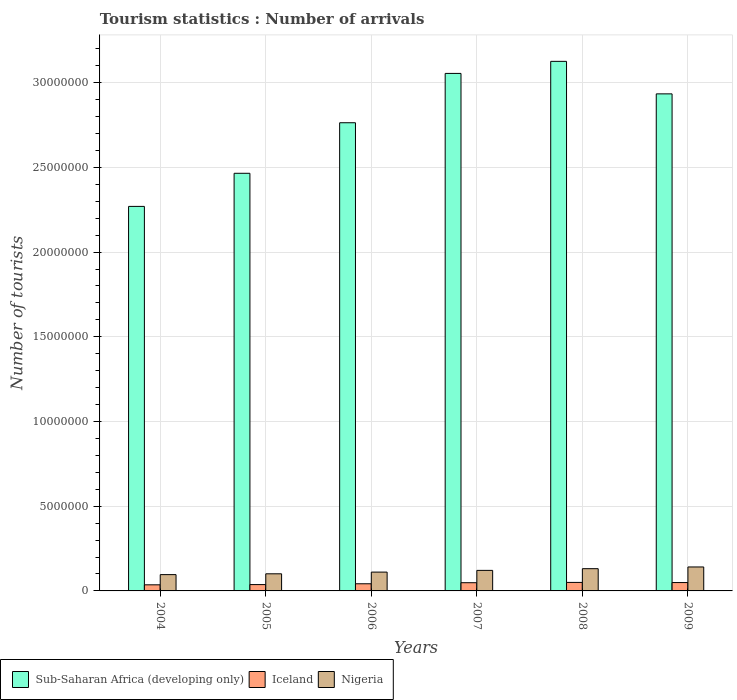How many different coloured bars are there?
Your response must be concise. 3. How many groups of bars are there?
Make the answer very short. 6. Are the number of bars on each tick of the X-axis equal?
Your answer should be very brief. Yes. How many bars are there on the 3rd tick from the left?
Provide a succinct answer. 3. How many bars are there on the 2nd tick from the right?
Make the answer very short. 3. What is the label of the 1st group of bars from the left?
Give a very brief answer. 2004. What is the number of tourist arrivals in Sub-Saharan Africa (developing only) in 2005?
Keep it short and to the point. 2.47e+07. Across all years, what is the maximum number of tourist arrivals in Nigeria?
Offer a terse response. 1.41e+06. Across all years, what is the minimum number of tourist arrivals in Sub-Saharan Africa (developing only)?
Give a very brief answer. 2.27e+07. In which year was the number of tourist arrivals in Sub-Saharan Africa (developing only) maximum?
Keep it short and to the point. 2008. In which year was the number of tourist arrivals in Nigeria minimum?
Provide a short and direct response. 2004. What is the total number of tourist arrivals in Nigeria in the graph?
Keep it short and to the point. 7.02e+06. What is the difference between the number of tourist arrivals in Nigeria in 2004 and that in 2006?
Your response must be concise. -1.49e+05. What is the difference between the number of tourist arrivals in Sub-Saharan Africa (developing only) in 2006 and the number of tourist arrivals in Nigeria in 2004?
Your answer should be compact. 2.67e+07. What is the average number of tourist arrivals in Sub-Saharan Africa (developing only) per year?
Provide a short and direct response. 2.77e+07. In the year 2005, what is the difference between the number of tourist arrivals in Sub-Saharan Africa (developing only) and number of tourist arrivals in Iceland?
Ensure brevity in your answer.  2.43e+07. What is the ratio of the number of tourist arrivals in Sub-Saharan Africa (developing only) in 2004 to that in 2006?
Provide a short and direct response. 0.82. What is the difference between the highest and the second highest number of tourist arrivals in Nigeria?
Keep it short and to the point. 1.01e+05. What is the difference between the highest and the lowest number of tourist arrivals in Nigeria?
Ensure brevity in your answer.  4.52e+05. In how many years, is the number of tourist arrivals in Nigeria greater than the average number of tourist arrivals in Nigeria taken over all years?
Offer a very short reply. 3. Is the sum of the number of tourist arrivals in Iceland in 2004 and 2005 greater than the maximum number of tourist arrivals in Nigeria across all years?
Give a very brief answer. No. What does the 3rd bar from the left in 2009 represents?
Your answer should be compact. Nigeria. How many bars are there?
Your answer should be compact. 18. How many years are there in the graph?
Give a very brief answer. 6. What is the difference between two consecutive major ticks on the Y-axis?
Offer a very short reply. 5.00e+06. Does the graph contain grids?
Provide a short and direct response. Yes. What is the title of the graph?
Ensure brevity in your answer.  Tourism statistics : Number of arrivals. What is the label or title of the X-axis?
Offer a terse response. Years. What is the label or title of the Y-axis?
Your response must be concise. Number of tourists. What is the Number of tourists in Sub-Saharan Africa (developing only) in 2004?
Offer a very short reply. 2.27e+07. What is the Number of tourists in Iceland in 2004?
Your answer should be very brief. 3.60e+05. What is the Number of tourists of Nigeria in 2004?
Ensure brevity in your answer.  9.62e+05. What is the Number of tourists in Sub-Saharan Africa (developing only) in 2005?
Provide a short and direct response. 2.47e+07. What is the Number of tourists in Iceland in 2005?
Provide a short and direct response. 3.74e+05. What is the Number of tourists in Nigeria in 2005?
Offer a terse response. 1.01e+06. What is the Number of tourists in Sub-Saharan Africa (developing only) in 2006?
Make the answer very short. 2.76e+07. What is the Number of tourists of Iceland in 2006?
Your answer should be compact. 4.22e+05. What is the Number of tourists of Nigeria in 2006?
Your response must be concise. 1.11e+06. What is the Number of tourists of Sub-Saharan Africa (developing only) in 2007?
Provide a short and direct response. 3.05e+07. What is the Number of tourists in Iceland in 2007?
Your response must be concise. 4.85e+05. What is the Number of tourists of Nigeria in 2007?
Provide a short and direct response. 1.21e+06. What is the Number of tourists in Sub-Saharan Africa (developing only) in 2008?
Your answer should be very brief. 3.13e+07. What is the Number of tourists in Iceland in 2008?
Your response must be concise. 5.02e+05. What is the Number of tourists in Nigeria in 2008?
Your answer should be compact. 1.31e+06. What is the Number of tourists in Sub-Saharan Africa (developing only) in 2009?
Give a very brief answer. 2.93e+07. What is the Number of tourists of Iceland in 2009?
Your answer should be very brief. 4.94e+05. What is the Number of tourists of Nigeria in 2009?
Your answer should be compact. 1.41e+06. Across all years, what is the maximum Number of tourists in Sub-Saharan Africa (developing only)?
Give a very brief answer. 3.13e+07. Across all years, what is the maximum Number of tourists in Iceland?
Give a very brief answer. 5.02e+05. Across all years, what is the maximum Number of tourists in Nigeria?
Your answer should be compact. 1.41e+06. Across all years, what is the minimum Number of tourists in Sub-Saharan Africa (developing only)?
Offer a terse response. 2.27e+07. Across all years, what is the minimum Number of tourists of Iceland?
Your answer should be very brief. 3.60e+05. Across all years, what is the minimum Number of tourists in Nigeria?
Offer a terse response. 9.62e+05. What is the total Number of tourists in Sub-Saharan Africa (developing only) in the graph?
Your answer should be very brief. 1.66e+08. What is the total Number of tourists of Iceland in the graph?
Provide a succinct answer. 2.64e+06. What is the total Number of tourists of Nigeria in the graph?
Ensure brevity in your answer.  7.02e+06. What is the difference between the Number of tourists of Sub-Saharan Africa (developing only) in 2004 and that in 2005?
Your answer should be compact. -1.95e+06. What is the difference between the Number of tourists in Iceland in 2004 and that in 2005?
Your response must be concise. -1.40e+04. What is the difference between the Number of tourists in Nigeria in 2004 and that in 2005?
Give a very brief answer. -4.80e+04. What is the difference between the Number of tourists in Sub-Saharan Africa (developing only) in 2004 and that in 2006?
Offer a terse response. -4.94e+06. What is the difference between the Number of tourists of Iceland in 2004 and that in 2006?
Offer a very short reply. -6.20e+04. What is the difference between the Number of tourists in Nigeria in 2004 and that in 2006?
Your answer should be compact. -1.49e+05. What is the difference between the Number of tourists in Sub-Saharan Africa (developing only) in 2004 and that in 2007?
Provide a short and direct response. -7.85e+06. What is the difference between the Number of tourists of Iceland in 2004 and that in 2007?
Provide a short and direct response. -1.25e+05. What is the difference between the Number of tourists of Sub-Saharan Africa (developing only) in 2004 and that in 2008?
Ensure brevity in your answer.  -8.56e+06. What is the difference between the Number of tourists in Iceland in 2004 and that in 2008?
Make the answer very short. -1.42e+05. What is the difference between the Number of tourists in Nigeria in 2004 and that in 2008?
Provide a succinct answer. -3.51e+05. What is the difference between the Number of tourists in Sub-Saharan Africa (developing only) in 2004 and that in 2009?
Your answer should be very brief. -6.64e+06. What is the difference between the Number of tourists of Iceland in 2004 and that in 2009?
Provide a succinct answer. -1.34e+05. What is the difference between the Number of tourists in Nigeria in 2004 and that in 2009?
Give a very brief answer. -4.52e+05. What is the difference between the Number of tourists in Sub-Saharan Africa (developing only) in 2005 and that in 2006?
Give a very brief answer. -2.98e+06. What is the difference between the Number of tourists of Iceland in 2005 and that in 2006?
Make the answer very short. -4.80e+04. What is the difference between the Number of tourists of Nigeria in 2005 and that in 2006?
Offer a terse response. -1.01e+05. What is the difference between the Number of tourists of Sub-Saharan Africa (developing only) in 2005 and that in 2007?
Your response must be concise. -5.89e+06. What is the difference between the Number of tourists in Iceland in 2005 and that in 2007?
Ensure brevity in your answer.  -1.11e+05. What is the difference between the Number of tourists in Nigeria in 2005 and that in 2007?
Offer a terse response. -2.02e+05. What is the difference between the Number of tourists of Sub-Saharan Africa (developing only) in 2005 and that in 2008?
Keep it short and to the point. -6.61e+06. What is the difference between the Number of tourists of Iceland in 2005 and that in 2008?
Offer a very short reply. -1.28e+05. What is the difference between the Number of tourists in Nigeria in 2005 and that in 2008?
Your answer should be compact. -3.03e+05. What is the difference between the Number of tourists of Sub-Saharan Africa (developing only) in 2005 and that in 2009?
Give a very brief answer. -4.69e+06. What is the difference between the Number of tourists of Nigeria in 2005 and that in 2009?
Your answer should be compact. -4.04e+05. What is the difference between the Number of tourists of Sub-Saharan Africa (developing only) in 2006 and that in 2007?
Provide a succinct answer. -2.91e+06. What is the difference between the Number of tourists in Iceland in 2006 and that in 2007?
Offer a very short reply. -6.30e+04. What is the difference between the Number of tourists of Nigeria in 2006 and that in 2007?
Your answer should be compact. -1.01e+05. What is the difference between the Number of tourists of Sub-Saharan Africa (developing only) in 2006 and that in 2008?
Give a very brief answer. -3.62e+06. What is the difference between the Number of tourists of Iceland in 2006 and that in 2008?
Offer a very short reply. -8.00e+04. What is the difference between the Number of tourists of Nigeria in 2006 and that in 2008?
Ensure brevity in your answer.  -2.02e+05. What is the difference between the Number of tourists in Sub-Saharan Africa (developing only) in 2006 and that in 2009?
Keep it short and to the point. -1.70e+06. What is the difference between the Number of tourists of Iceland in 2006 and that in 2009?
Your response must be concise. -7.20e+04. What is the difference between the Number of tourists of Nigeria in 2006 and that in 2009?
Make the answer very short. -3.03e+05. What is the difference between the Number of tourists in Sub-Saharan Africa (developing only) in 2007 and that in 2008?
Ensure brevity in your answer.  -7.12e+05. What is the difference between the Number of tourists of Iceland in 2007 and that in 2008?
Make the answer very short. -1.70e+04. What is the difference between the Number of tourists of Nigeria in 2007 and that in 2008?
Make the answer very short. -1.01e+05. What is the difference between the Number of tourists of Sub-Saharan Africa (developing only) in 2007 and that in 2009?
Your response must be concise. 1.21e+06. What is the difference between the Number of tourists of Iceland in 2007 and that in 2009?
Keep it short and to the point. -9000. What is the difference between the Number of tourists in Nigeria in 2007 and that in 2009?
Provide a short and direct response. -2.02e+05. What is the difference between the Number of tourists in Sub-Saharan Africa (developing only) in 2008 and that in 2009?
Offer a very short reply. 1.92e+06. What is the difference between the Number of tourists in Iceland in 2008 and that in 2009?
Provide a succinct answer. 8000. What is the difference between the Number of tourists of Nigeria in 2008 and that in 2009?
Provide a short and direct response. -1.01e+05. What is the difference between the Number of tourists of Sub-Saharan Africa (developing only) in 2004 and the Number of tourists of Iceland in 2005?
Ensure brevity in your answer.  2.23e+07. What is the difference between the Number of tourists in Sub-Saharan Africa (developing only) in 2004 and the Number of tourists in Nigeria in 2005?
Your answer should be compact. 2.17e+07. What is the difference between the Number of tourists of Iceland in 2004 and the Number of tourists of Nigeria in 2005?
Make the answer very short. -6.50e+05. What is the difference between the Number of tourists in Sub-Saharan Africa (developing only) in 2004 and the Number of tourists in Iceland in 2006?
Provide a short and direct response. 2.23e+07. What is the difference between the Number of tourists in Sub-Saharan Africa (developing only) in 2004 and the Number of tourists in Nigeria in 2006?
Offer a very short reply. 2.16e+07. What is the difference between the Number of tourists in Iceland in 2004 and the Number of tourists in Nigeria in 2006?
Your answer should be compact. -7.51e+05. What is the difference between the Number of tourists of Sub-Saharan Africa (developing only) in 2004 and the Number of tourists of Iceland in 2007?
Keep it short and to the point. 2.22e+07. What is the difference between the Number of tourists of Sub-Saharan Africa (developing only) in 2004 and the Number of tourists of Nigeria in 2007?
Keep it short and to the point. 2.15e+07. What is the difference between the Number of tourists of Iceland in 2004 and the Number of tourists of Nigeria in 2007?
Your response must be concise. -8.52e+05. What is the difference between the Number of tourists of Sub-Saharan Africa (developing only) in 2004 and the Number of tourists of Iceland in 2008?
Keep it short and to the point. 2.22e+07. What is the difference between the Number of tourists in Sub-Saharan Africa (developing only) in 2004 and the Number of tourists in Nigeria in 2008?
Your answer should be compact. 2.14e+07. What is the difference between the Number of tourists in Iceland in 2004 and the Number of tourists in Nigeria in 2008?
Make the answer very short. -9.53e+05. What is the difference between the Number of tourists in Sub-Saharan Africa (developing only) in 2004 and the Number of tourists in Iceland in 2009?
Provide a succinct answer. 2.22e+07. What is the difference between the Number of tourists in Sub-Saharan Africa (developing only) in 2004 and the Number of tourists in Nigeria in 2009?
Your answer should be very brief. 2.13e+07. What is the difference between the Number of tourists of Iceland in 2004 and the Number of tourists of Nigeria in 2009?
Keep it short and to the point. -1.05e+06. What is the difference between the Number of tourists in Sub-Saharan Africa (developing only) in 2005 and the Number of tourists in Iceland in 2006?
Provide a succinct answer. 2.42e+07. What is the difference between the Number of tourists in Sub-Saharan Africa (developing only) in 2005 and the Number of tourists in Nigeria in 2006?
Offer a very short reply. 2.35e+07. What is the difference between the Number of tourists in Iceland in 2005 and the Number of tourists in Nigeria in 2006?
Keep it short and to the point. -7.37e+05. What is the difference between the Number of tourists in Sub-Saharan Africa (developing only) in 2005 and the Number of tourists in Iceland in 2007?
Your answer should be very brief. 2.42e+07. What is the difference between the Number of tourists in Sub-Saharan Africa (developing only) in 2005 and the Number of tourists in Nigeria in 2007?
Ensure brevity in your answer.  2.34e+07. What is the difference between the Number of tourists in Iceland in 2005 and the Number of tourists in Nigeria in 2007?
Offer a very short reply. -8.38e+05. What is the difference between the Number of tourists of Sub-Saharan Africa (developing only) in 2005 and the Number of tourists of Iceland in 2008?
Ensure brevity in your answer.  2.41e+07. What is the difference between the Number of tourists of Sub-Saharan Africa (developing only) in 2005 and the Number of tourists of Nigeria in 2008?
Your answer should be compact. 2.33e+07. What is the difference between the Number of tourists of Iceland in 2005 and the Number of tourists of Nigeria in 2008?
Keep it short and to the point. -9.39e+05. What is the difference between the Number of tourists in Sub-Saharan Africa (developing only) in 2005 and the Number of tourists in Iceland in 2009?
Give a very brief answer. 2.42e+07. What is the difference between the Number of tourists of Sub-Saharan Africa (developing only) in 2005 and the Number of tourists of Nigeria in 2009?
Provide a short and direct response. 2.32e+07. What is the difference between the Number of tourists in Iceland in 2005 and the Number of tourists in Nigeria in 2009?
Keep it short and to the point. -1.04e+06. What is the difference between the Number of tourists of Sub-Saharan Africa (developing only) in 2006 and the Number of tourists of Iceland in 2007?
Offer a terse response. 2.71e+07. What is the difference between the Number of tourists in Sub-Saharan Africa (developing only) in 2006 and the Number of tourists in Nigeria in 2007?
Make the answer very short. 2.64e+07. What is the difference between the Number of tourists of Iceland in 2006 and the Number of tourists of Nigeria in 2007?
Provide a succinct answer. -7.90e+05. What is the difference between the Number of tourists in Sub-Saharan Africa (developing only) in 2006 and the Number of tourists in Iceland in 2008?
Offer a very short reply. 2.71e+07. What is the difference between the Number of tourists of Sub-Saharan Africa (developing only) in 2006 and the Number of tourists of Nigeria in 2008?
Make the answer very short. 2.63e+07. What is the difference between the Number of tourists in Iceland in 2006 and the Number of tourists in Nigeria in 2008?
Your response must be concise. -8.91e+05. What is the difference between the Number of tourists in Sub-Saharan Africa (developing only) in 2006 and the Number of tourists in Iceland in 2009?
Make the answer very short. 2.71e+07. What is the difference between the Number of tourists in Sub-Saharan Africa (developing only) in 2006 and the Number of tourists in Nigeria in 2009?
Keep it short and to the point. 2.62e+07. What is the difference between the Number of tourists in Iceland in 2006 and the Number of tourists in Nigeria in 2009?
Ensure brevity in your answer.  -9.92e+05. What is the difference between the Number of tourists of Sub-Saharan Africa (developing only) in 2007 and the Number of tourists of Iceland in 2008?
Provide a short and direct response. 3.00e+07. What is the difference between the Number of tourists in Sub-Saharan Africa (developing only) in 2007 and the Number of tourists in Nigeria in 2008?
Make the answer very short. 2.92e+07. What is the difference between the Number of tourists in Iceland in 2007 and the Number of tourists in Nigeria in 2008?
Your answer should be compact. -8.28e+05. What is the difference between the Number of tourists in Sub-Saharan Africa (developing only) in 2007 and the Number of tourists in Iceland in 2009?
Make the answer very short. 3.01e+07. What is the difference between the Number of tourists of Sub-Saharan Africa (developing only) in 2007 and the Number of tourists of Nigeria in 2009?
Offer a very short reply. 2.91e+07. What is the difference between the Number of tourists in Iceland in 2007 and the Number of tourists in Nigeria in 2009?
Your answer should be compact. -9.29e+05. What is the difference between the Number of tourists in Sub-Saharan Africa (developing only) in 2008 and the Number of tourists in Iceland in 2009?
Your answer should be compact. 3.08e+07. What is the difference between the Number of tourists of Sub-Saharan Africa (developing only) in 2008 and the Number of tourists of Nigeria in 2009?
Offer a very short reply. 2.98e+07. What is the difference between the Number of tourists of Iceland in 2008 and the Number of tourists of Nigeria in 2009?
Provide a succinct answer. -9.12e+05. What is the average Number of tourists of Sub-Saharan Africa (developing only) per year?
Give a very brief answer. 2.77e+07. What is the average Number of tourists of Iceland per year?
Your response must be concise. 4.40e+05. What is the average Number of tourists in Nigeria per year?
Keep it short and to the point. 1.17e+06. In the year 2004, what is the difference between the Number of tourists in Sub-Saharan Africa (developing only) and Number of tourists in Iceland?
Ensure brevity in your answer.  2.23e+07. In the year 2004, what is the difference between the Number of tourists in Sub-Saharan Africa (developing only) and Number of tourists in Nigeria?
Offer a terse response. 2.17e+07. In the year 2004, what is the difference between the Number of tourists of Iceland and Number of tourists of Nigeria?
Ensure brevity in your answer.  -6.02e+05. In the year 2005, what is the difference between the Number of tourists in Sub-Saharan Africa (developing only) and Number of tourists in Iceland?
Your answer should be compact. 2.43e+07. In the year 2005, what is the difference between the Number of tourists of Sub-Saharan Africa (developing only) and Number of tourists of Nigeria?
Your answer should be very brief. 2.36e+07. In the year 2005, what is the difference between the Number of tourists of Iceland and Number of tourists of Nigeria?
Your answer should be compact. -6.36e+05. In the year 2006, what is the difference between the Number of tourists in Sub-Saharan Africa (developing only) and Number of tourists in Iceland?
Your answer should be very brief. 2.72e+07. In the year 2006, what is the difference between the Number of tourists in Sub-Saharan Africa (developing only) and Number of tourists in Nigeria?
Offer a very short reply. 2.65e+07. In the year 2006, what is the difference between the Number of tourists in Iceland and Number of tourists in Nigeria?
Make the answer very short. -6.89e+05. In the year 2007, what is the difference between the Number of tourists of Sub-Saharan Africa (developing only) and Number of tourists of Iceland?
Offer a very short reply. 3.01e+07. In the year 2007, what is the difference between the Number of tourists in Sub-Saharan Africa (developing only) and Number of tourists in Nigeria?
Ensure brevity in your answer.  2.93e+07. In the year 2007, what is the difference between the Number of tourists in Iceland and Number of tourists in Nigeria?
Provide a succinct answer. -7.27e+05. In the year 2008, what is the difference between the Number of tourists in Sub-Saharan Africa (developing only) and Number of tourists in Iceland?
Your answer should be very brief. 3.08e+07. In the year 2008, what is the difference between the Number of tourists of Sub-Saharan Africa (developing only) and Number of tourists of Nigeria?
Provide a succinct answer. 2.99e+07. In the year 2008, what is the difference between the Number of tourists of Iceland and Number of tourists of Nigeria?
Make the answer very short. -8.11e+05. In the year 2009, what is the difference between the Number of tourists in Sub-Saharan Africa (developing only) and Number of tourists in Iceland?
Your answer should be compact. 2.88e+07. In the year 2009, what is the difference between the Number of tourists in Sub-Saharan Africa (developing only) and Number of tourists in Nigeria?
Keep it short and to the point. 2.79e+07. In the year 2009, what is the difference between the Number of tourists of Iceland and Number of tourists of Nigeria?
Offer a terse response. -9.20e+05. What is the ratio of the Number of tourists of Sub-Saharan Africa (developing only) in 2004 to that in 2005?
Make the answer very short. 0.92. What is the ratio of the Number of tourists of Iceland in 2004 to that in 2005?
Make the answer very short. 0.96. What is the ratio of the Number of tourists in Nigeria in 2004 to that in 2005?
Offer a terse response. 0.95. What is the ratio of the Number of tourists in Sub-Saharan Africa (developing only) in 2004 to that in 2006?
Offer a very short reply. 0.82. What is the ratio of the Number of tourists in Iceland in 2004 to that in 2006?
Give a very brief answer. 0.85. What is the ratio of the Number of tourists of Nigeria in 2004 to that in 2006?
Your answer should be very brief. 0.87. What is the ratio of the Number of tourists of Sub-Saharan Africa (developing only) in 2004 to that in 2007?
Keep it short and to the point. 0.74. What is the ratio of the Number of tourists of Iceland in 2004 to that in 2007?
Give a very brief answer. 0.74. What is the ratio of the Number of tourists in Nigeria in 2004 to that in 2007?
Your response must be concise. 0.79. What is the ratio of the Number of tourists of Sub-Saharan Africa (developing only) in 2004 to that in 2008?
Give a very brief answer. 0.73. What is the ratio of the Number of tourists of Iceland in 2004 to that in 2008?
Offer a terse response. 0.72. What is the ratio of the Number of tourists of Nigeria in 2004 to that in 2008?
Offer a very short reply. 0.73. What is the ratio of the Number of tourists in Sub-Saharan Africa (developing only) in 2004 to that in 2009?
Your answer should be compact. 0.77. What is the ratio of the Number of tourists in Iceland in 2004 to that in 2009?
Give a very brief answer. 0.73. What is the ratio of the Number of tourists in Nigeria in 2004 to that in 2009?
Your answer should be very brief. 0.68. What is the ratio of the Number of tourists in Sub-Saharan Africa (developing only) in 2005 to that in 2006?
Keep it short and to the point. 0.89. What is the ratio of the Number of tourists of Iceland in 2005 to that in 2006?
Provide a succinct answer. 0.89. What is the ratio of the Number of tourists of Nigeria in 2005 to that in 2006?
Provide a succinct answer. 0.91. What is the ratio of the Number of tourists of Sub-Saharan Africa (developing only) in 2005 to that in 2007?
Offer a very short reply. 0.81. What is the ratio of the Number of tourists in Iceland in 2005 to that in 2007?
Your answer should be very brief. 0.77. What is the ratio of the Number of tourists in Sub-Saharan Africa (developing only) in 2005 to that in 2008?
Give a very brief answer. 0.79. What is the ratio of the Number of tourists of Iceland in 2005 to that in 2008?
Provide a succinct answer. 0.74. What is the ratio of the Number of tourists in Nigeria in 2005 to that in 2008?
Provide a short and direct response. 0.77. What is the ratio of the Number of tourists of Sub-Saharan Africa (developing only) in 2005 to that in 2009?
Provide a succinct answer. 0.84. What is the ratio of the Number of tourists of Iceland in 2005 to that in 2009?
Your answer should be compact. 0.76. What is the ratio of the Number of tourists in Sub-Saharan Africa (developing only) in 2006 to that in 2007?
Give a very brief answer. 0.9. What is the ratio of the Number of tourists of Iceland in 2006 to that in 2007?
Offer a terse response. 0.87. What is the ratio of the Number of tourists of Nigeria in 2006 to that in 2007?
Keep it short and to the point. 0.92. What is the ratio of the Number of tourists in Sub-Saharan Africa (developing only) in 2006 to that in 2008?
Give a very brief answer. 0.88. What is the ratio of the Number of tourists in Iceland in 2006 to that in 2008?
Your answer should be very brief. 0.84. What is the ratio of the Number of tourists in Nigeria in 2006 to that in 2008?
Provide a succinct answer. 0.85. What is the ratio of the Number of tourists of Sub-Saharan Africa (developing only) in 2006 to that in 2009?
Provide a short and direct response. 0.94. What is the ratio of the Number of tourists of Iceland in 2006 to that in 2009?
Offer a terse response. 0.85. What is the ratio of the Number of tourists in Nigeria in 2006 to that in 2009?
Give a very brief answer. 0.79. What is the ratio of the Number of tourists of Sub-Saharan Africa (developing only) in 2007 to that in 2008?
Offer a very short reply. 0.98. What is the ratio of the Number of tourists of Iceland in 2007 to that in 2008?
Provide a succinct answer. 0.97. What is the ratio of the Number of tourists in Sub-Saharan Africa (developing only) in 2007 to that in 2009?
Your answer should be very brief. 1.04. What is the ratio of the Number of tourists in Iceland in 2007 to that in 2009?
Your answer should be compact. 0.98. What is the ratio of the Number of tourists of Nigeria in 2007 to that in 2009?
Ensure brevity in your answer.  0.86. What is the ratio of the Number of tourists of Sub-Saharan Africa (developing only) in 2008 to that in 2009?
Keep it short and to the point. 1.07. What is the ratio of the Number of tourists of Iceland in 2008 to that in 2009?
Ensure brevity in your answer.  1.02. What is the difference between the highest and the second highest Number of tourists in Sub-Saharan Africa (developing only)?
Provide a succinct answer. 7.12e+05. What is the difference between the highest and the second highest Number of tourists of Iceland?
Ensure brevity in your answer.  8000. What is the difference between the highest and the second highest Number of tourists in Nigeria?
Offer a terse response. 1.01e+05. What is the difference between the highest and the lowest Number of tourists in Sub-Saharan Africa (developing only)?
Provide a succinct answer. 8.56e+06. What is the difference between the highest and the lowest Number of tourists in Iceland?
Your answer should be very brief. 1.42e+05. What is the difference between the highest and the lowest Number of tourists of Nigeria?
Make the answer very short. 4.52e+05. 